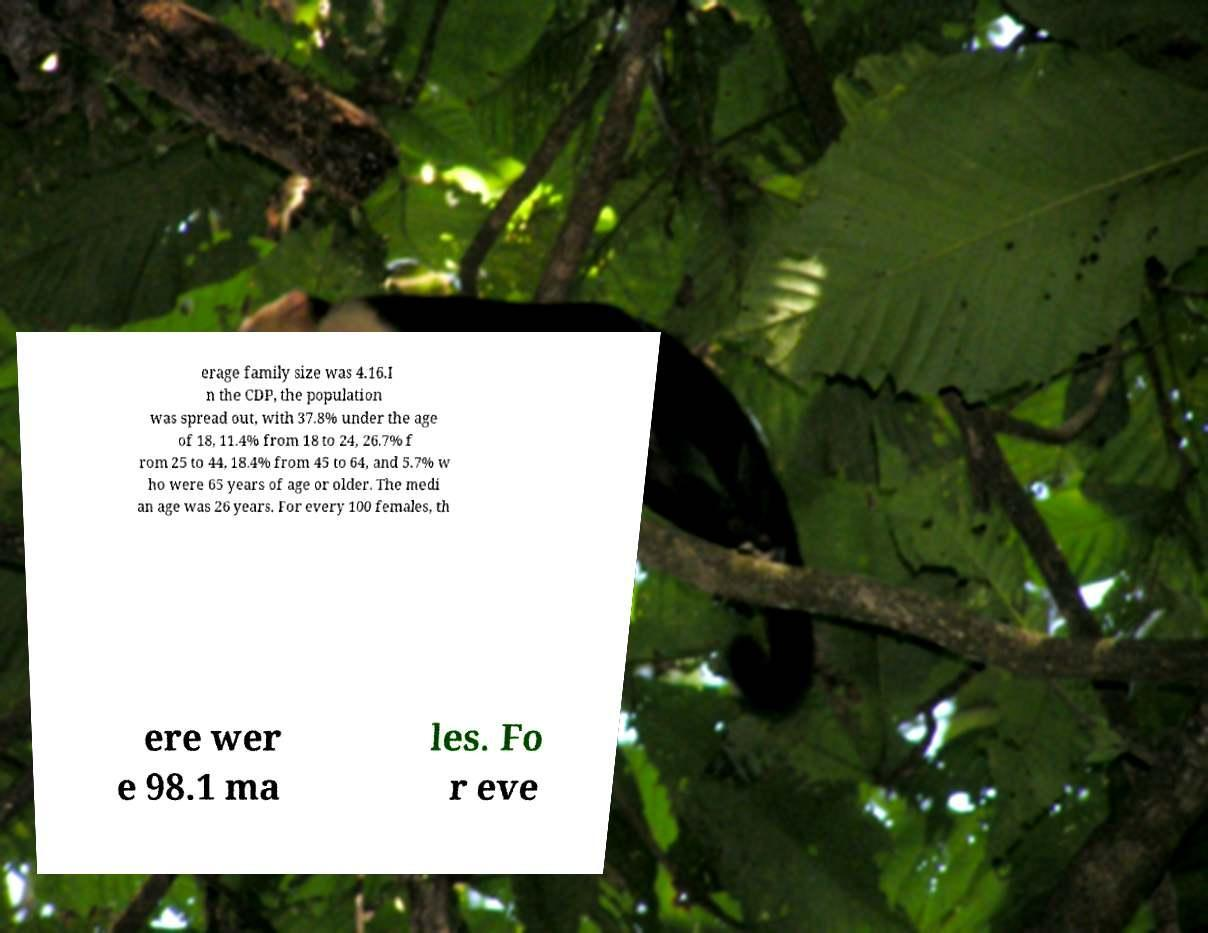Could you extract and type out the text from this image? erage family size was 4.16.I n the CDP, the population was spread out, with 37.8% under the age of 18, 11.4% from 18 to 24, 26.7% f rom 25 to 44, 18.4% from 45 to 64, and 5.7% w ho were 65 years of age or older. The medi an age was 26 years. For every 100 females, th ere wer e 98.1 ma les. Fo r eve 